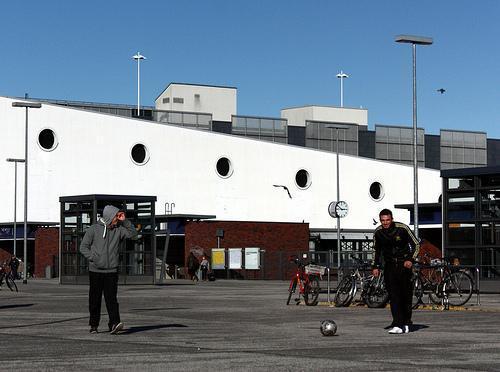How many soccer balls are there?
Give a very brief answer. 1. 